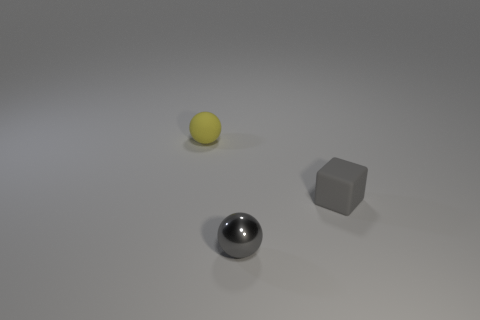Add 3 yellow things. How many objects exist? 6 Subtract all balls. How many objects are left? 1 Subtract 0 cyan cylinders. How many objects are left? 3 Subtract all small blue objects. Subtract all tiny things. How many objects are left? 0 Add 1 small metallic balls. How many small metallic balls are left? 2 Add 3 tiny gray spheres. How many tiny gray spheres exist? 4 